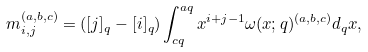<formula> <loc_0><loc_0><loc_500><loc_500>m _ { i , j } ^ { ( a , b , c ) } = ( [ j ] _ { q } - [ i ] _ { q } ) \int _ { c q } ^ { a q } x ^ { i + j - 1 } \omega ( x ; q ) ^ { ( a , b , c ) } d _ { q } x ,</formula> 